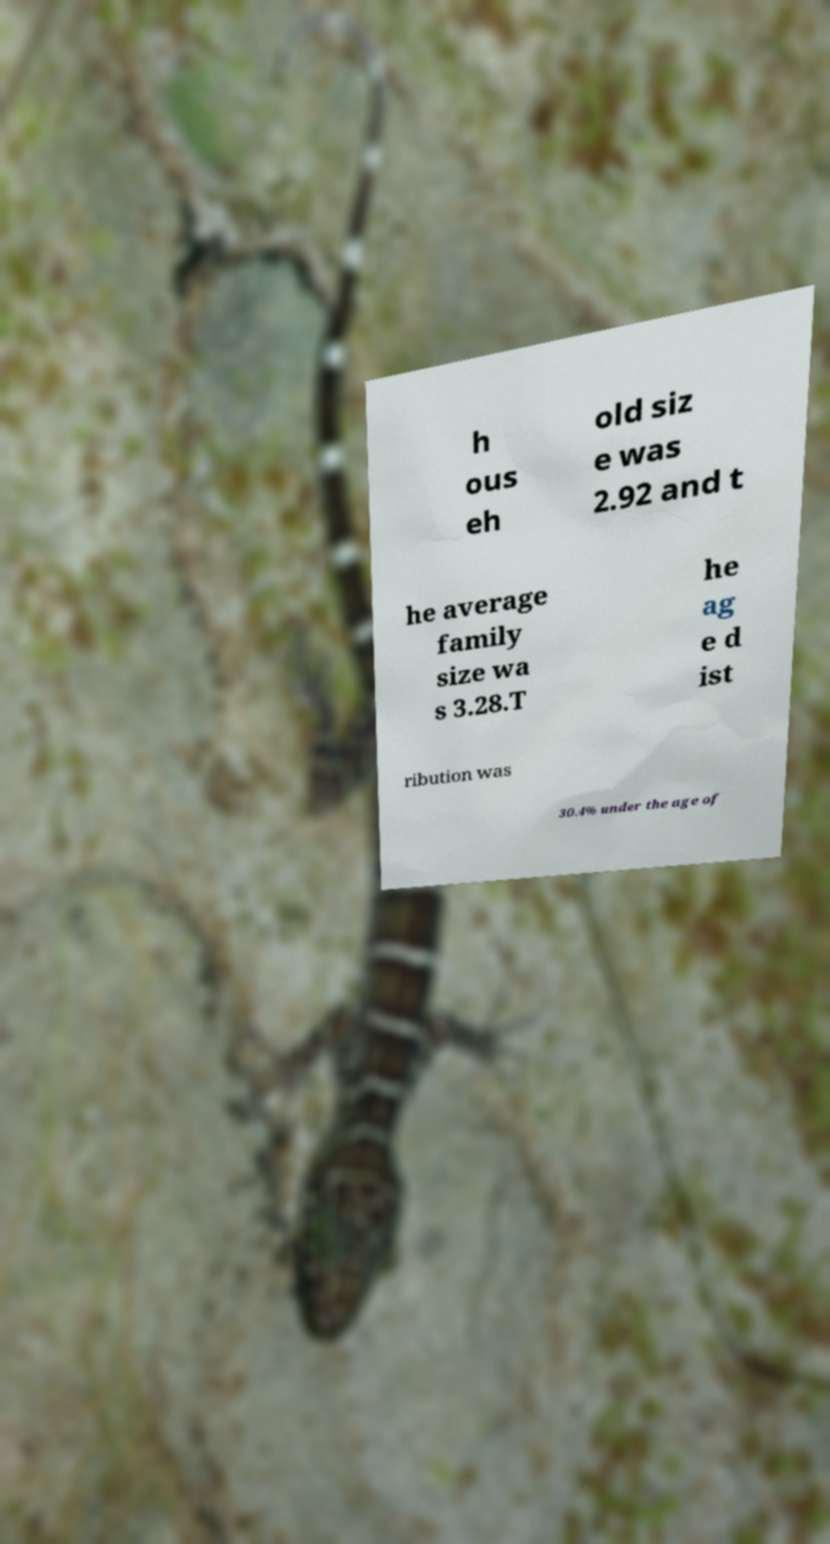Could you extract and type out the text from this image? h ous eh old siz e was 2.92 and t he average family size wa s 3.28.T he ag e d ist ribution was 30.4% under the age of 